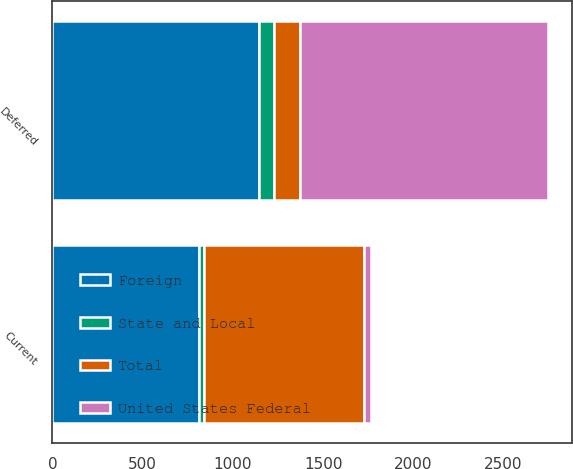Convert chart. <chart><loc_0><loc_0><loc_500><loc_500><stacked_bar_chart><ecel><fcel>Current<fcel>Deferred<nl><fcel>Foreign<fcel>810<fcel>1146<nl><fcel>State and Local<fcel>31<fcel>83<nl><fcel>Total<fcel>883<fcel>143<nl><fcel>United States Federal<fcel>42<fcel>1372<nl></chart> 